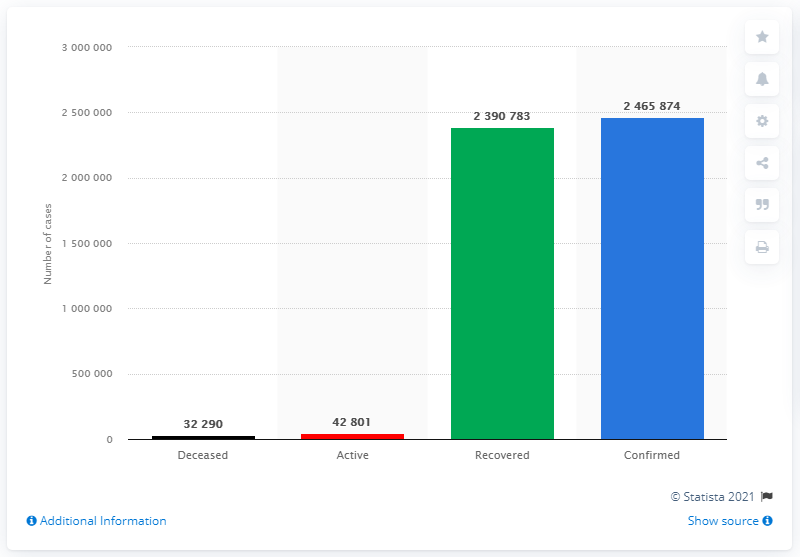Specify some key components in this picture. There have been a total of 239,078 COVID-19 cases reported in Tamil Nadu as of June 27, 2021. As of February 23, 2023, it is estimated that a total of 32,290 people have died from COVID-19. 